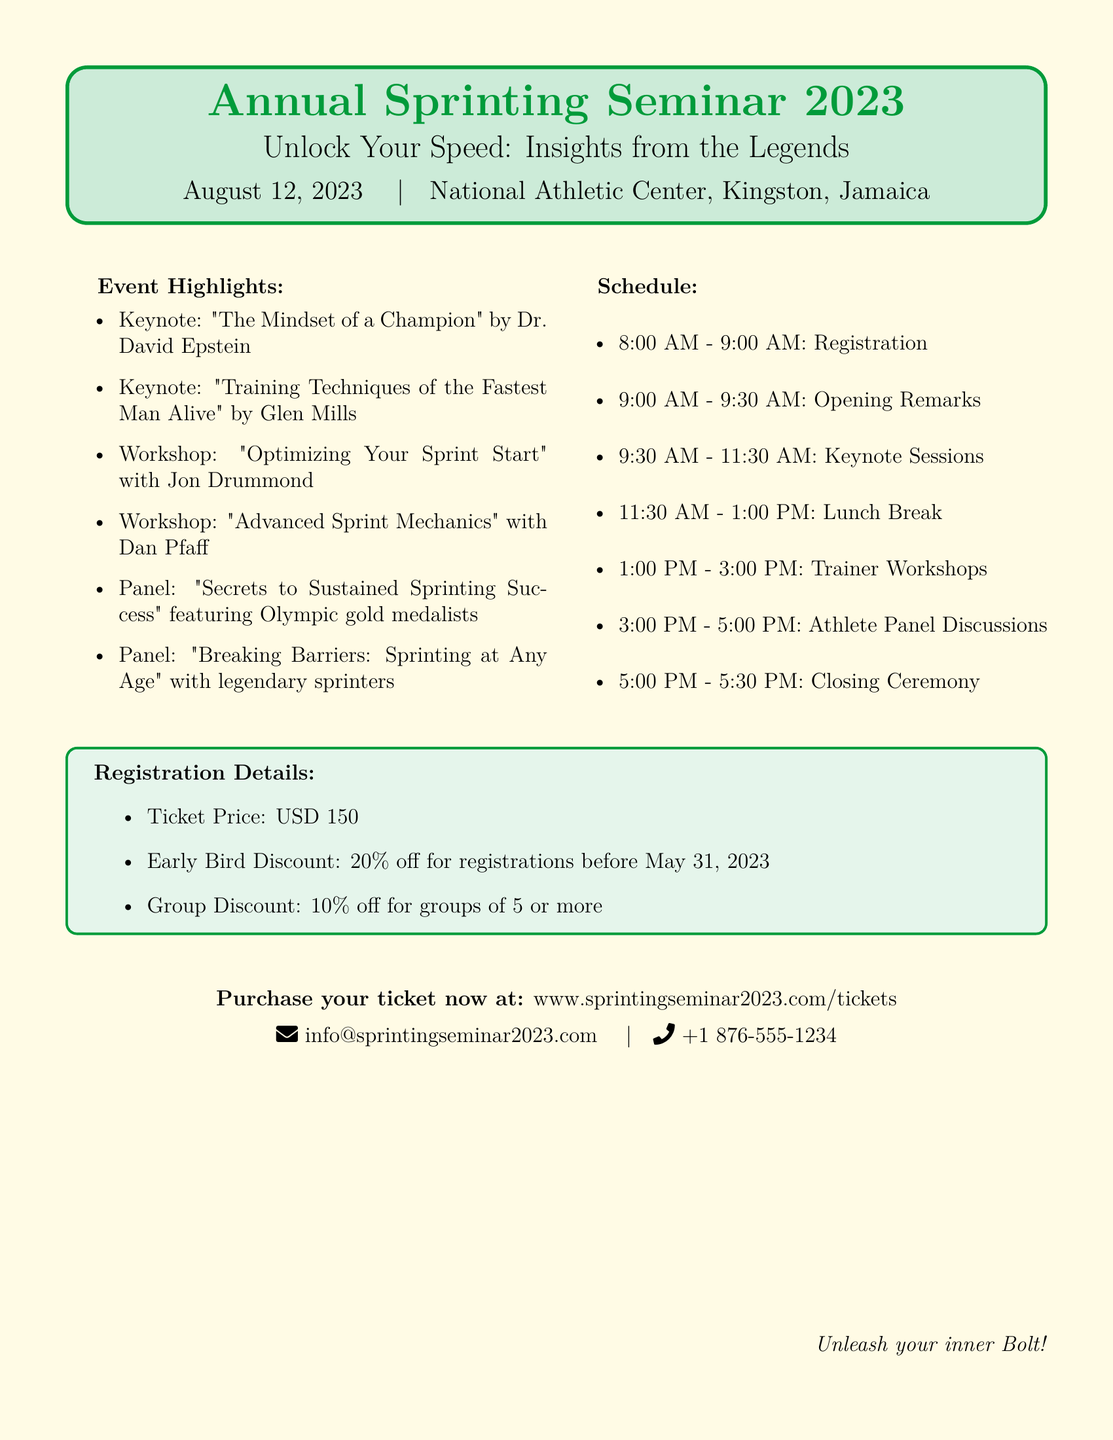What is the ticket price? The ticket price is explicitly stated in the document.
Answer: USD 150 What date is the seminar scheduled for? The document mentions the specific date of the seminar.
Answer: August 12, 2023 Who is the keynote speaker for 'Training Techniques of the Fastest Man Alive'? The document lists the speakers for the keynote sessions.
Answer: Glen Mills What time does the registration start? The schedule section provides details about the timing of registration.
Answer: 8:00 AM What discount is available for early bird registrations? The document specifies the discount for early registrations.
Answer: 20% off How many panels are featured in the seminar? The event highlights indicate the number of panel discussions scheduled.
Answer: 2 panels What is the duration of the lunch break? The schedule section provides the duration of the lunch break.
Answer: 1 hour What is one of the topics covered in the trainer workshops? The document lists the topics of the workshops offered during the seminar.
Answer: Optimizing Your Sprint Start What is the venue for the seminar? The location of the seminar is provided at the beginning of the document.
Answer: National Athletic Center, Kingston, Jamaica 